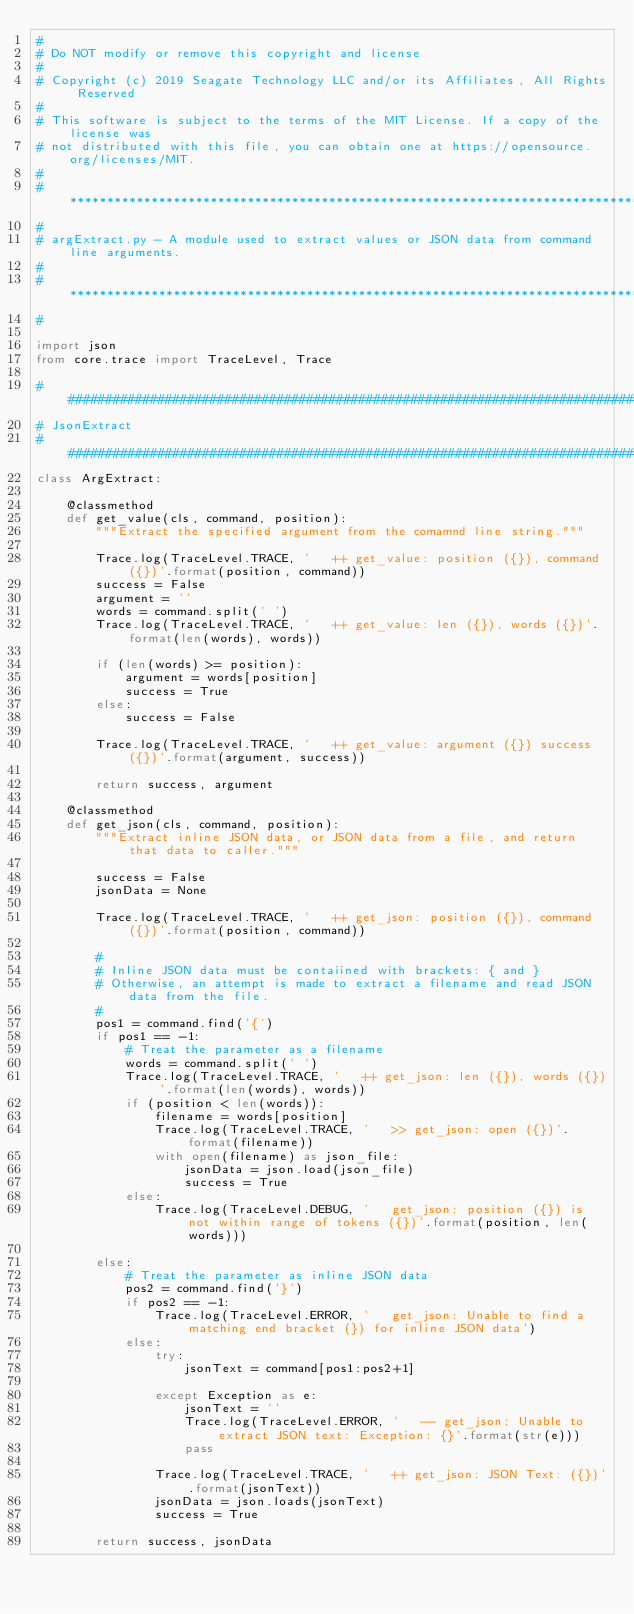Convert code to text. <code><loc_0><loc_0><loc_500><loc_500><_Python_>#
# Do NOT modify or remove this copyright and license
#
# Copyright (c) 2019 Seagate Technology LLC and/or its Affiliates, All Rights Reserved
#
# This software is subject to the terms of the MIT License. If a copy of the license was
# not distributed with this file, you can obtain one at https://opensource.org/licenses/MIT.
#
# ******************************************************************************************
#
# argExtract.py - A module used to extract values or JSON data from command line arguments. 
#
# ******************************************************************************************
#

import json
from core.trace import TraceLevel, Trace

################################################################################
# JsonExtract
################################################################################
class ArgExtract:

    @classmethod
    def get_value(cls, command, position):
        """Extract the specified argument from the comamnd line string."""

        Trace.log(TraceLevel.TRACE, '   ++ get_value: position ({}), command ({})'.format(position, command))
        success = False
        argument = ''
        words = command.split(' ')
        Trace.log(TraceLevel.TRACE, '   ++ get_value: len ({}), words ({})'.format(len(words), words))

        if (len(words) >= position):
            argument = words[position]
            success = True
        else:
            success = False

        Trace.log(TraceLevel.TRACE, '   ++ get_value: argument ({}) success ({})'.format(argument, success))

        return success, argument

    @classmethod
    def get_json(cls, command, position):
        """Extract inline JSON data, or JSON data from a file, and return that data to caller."""

        success = False
        jsonData = None

        Trace.log(TraceLevel.TRACE, '   ++ get_json: position ({}), command ({})'.format(position, command))

        #
        # Inline JSON data must be contaiined with brackets: { and }
        # Otherwise, an attempt is made to extract a filename and read JSON data from the file.
        # 
        pos1 = command.find('{')
        if pos1 == -1:
            # Treat the parameter as a filename
            words = command.split(' ')
            Trace.log(TraceLevel.TRACE, '   ++ get_json: len ({}), words ({})'.format(len(words), words))
            if (position < len(words)):
                filename = words[position]
                Trace.log(TraceLevel.TRACE, '   >> get_json: open ({})'.format(filename))
                with open(filename) as json_file:
                    jsonData = json.load(json_file)
                    success = True
            else:
                Trace.log(TraceLevel.DEBUG, '   get_json: position ({}) is not within range of tokens ({})'.format(position, len(words)))

        else:
            # Treat the parameter as inline JSON data
            pos2 = command.find('}')
            if pos2 == -1:
                Trace.log(TraceLevel.ERROR, '   get_json: Unable to find a matching end bracket (}) for inline JSON data')
            else:
                try:
                    jsonText = command[pos1:pos2+1]

                except Exception as e:
                    jsonText = ''
                    Trace.log(TraceLevel.ERROR, '   -- get_json: Unable to extract JSON text: Exception: {}'.format(str(e)))
                    pass

                Trace.log(TraceLevel.TRACE, '   ++ get_json: JSON Text: ({})'.format(jsonText))
                jsonData = json.loads(jsonText)
                success = True

        return success, jsonData
</code> 